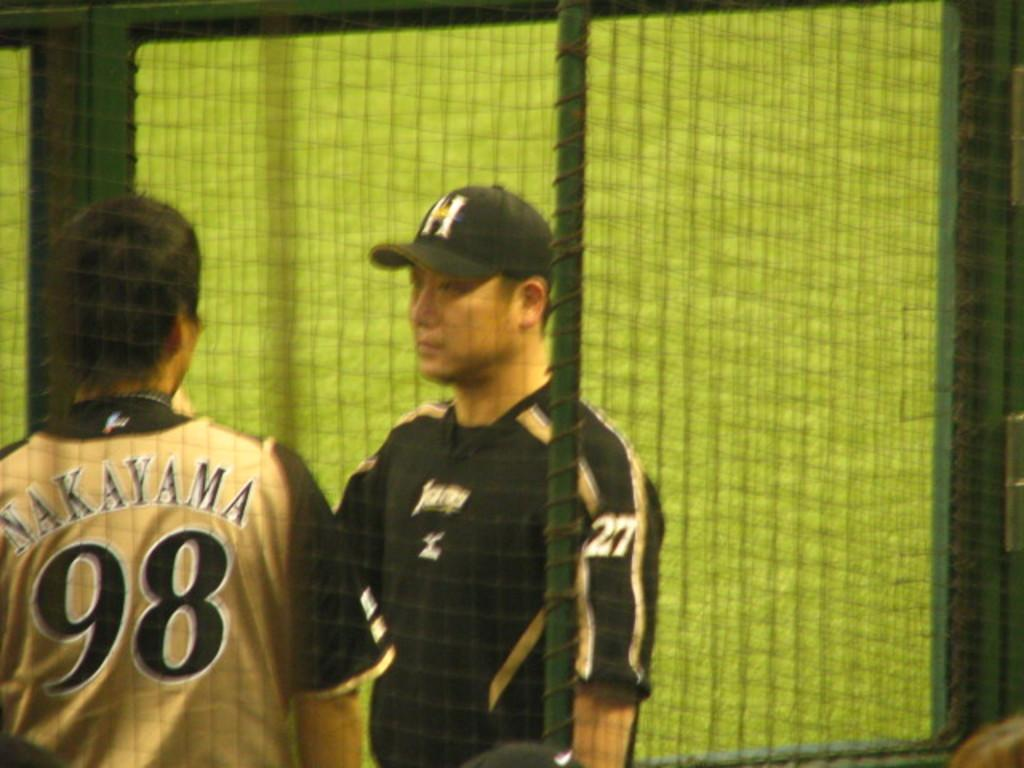<image>
Render a clear and concise summary of the photo. A man in a gold and black baseball uniform with Yakayama on the back talks to another man. 